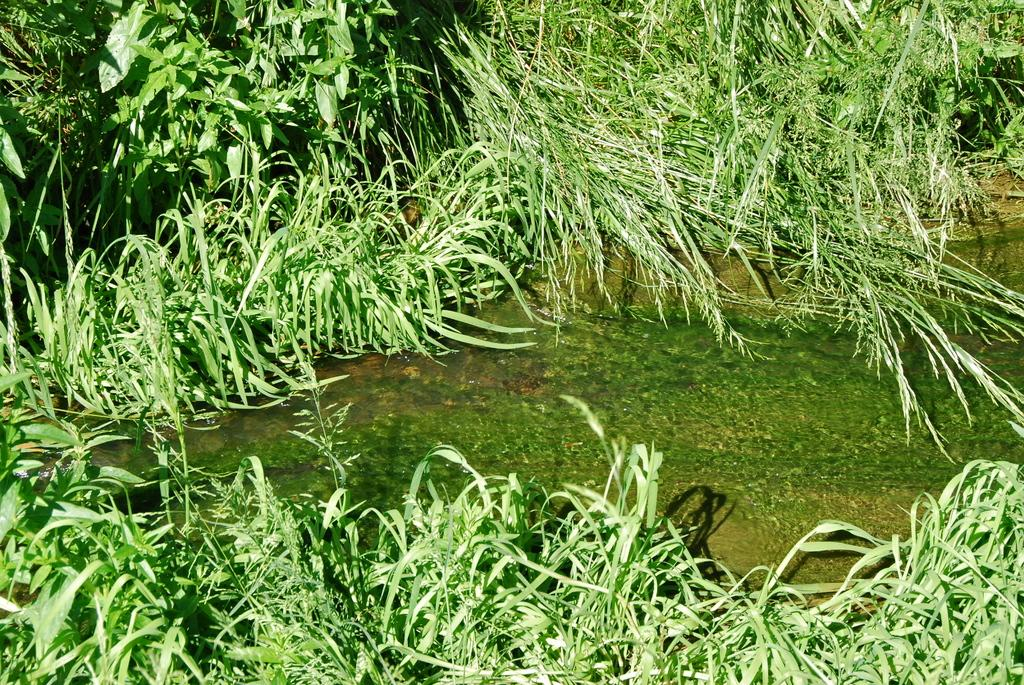What type of vegetation can be seen in the image? There is green grass in the image. What other type of plant can be seen in the image? There are plants in the image. What natural element is visible in the image? There is water visible in the image. How many geese are flying over the plants in the image? There are no geese visible in the image; it only features green grass, plants, and water. What type of paper is present in the image? There is no paper present in the image. 